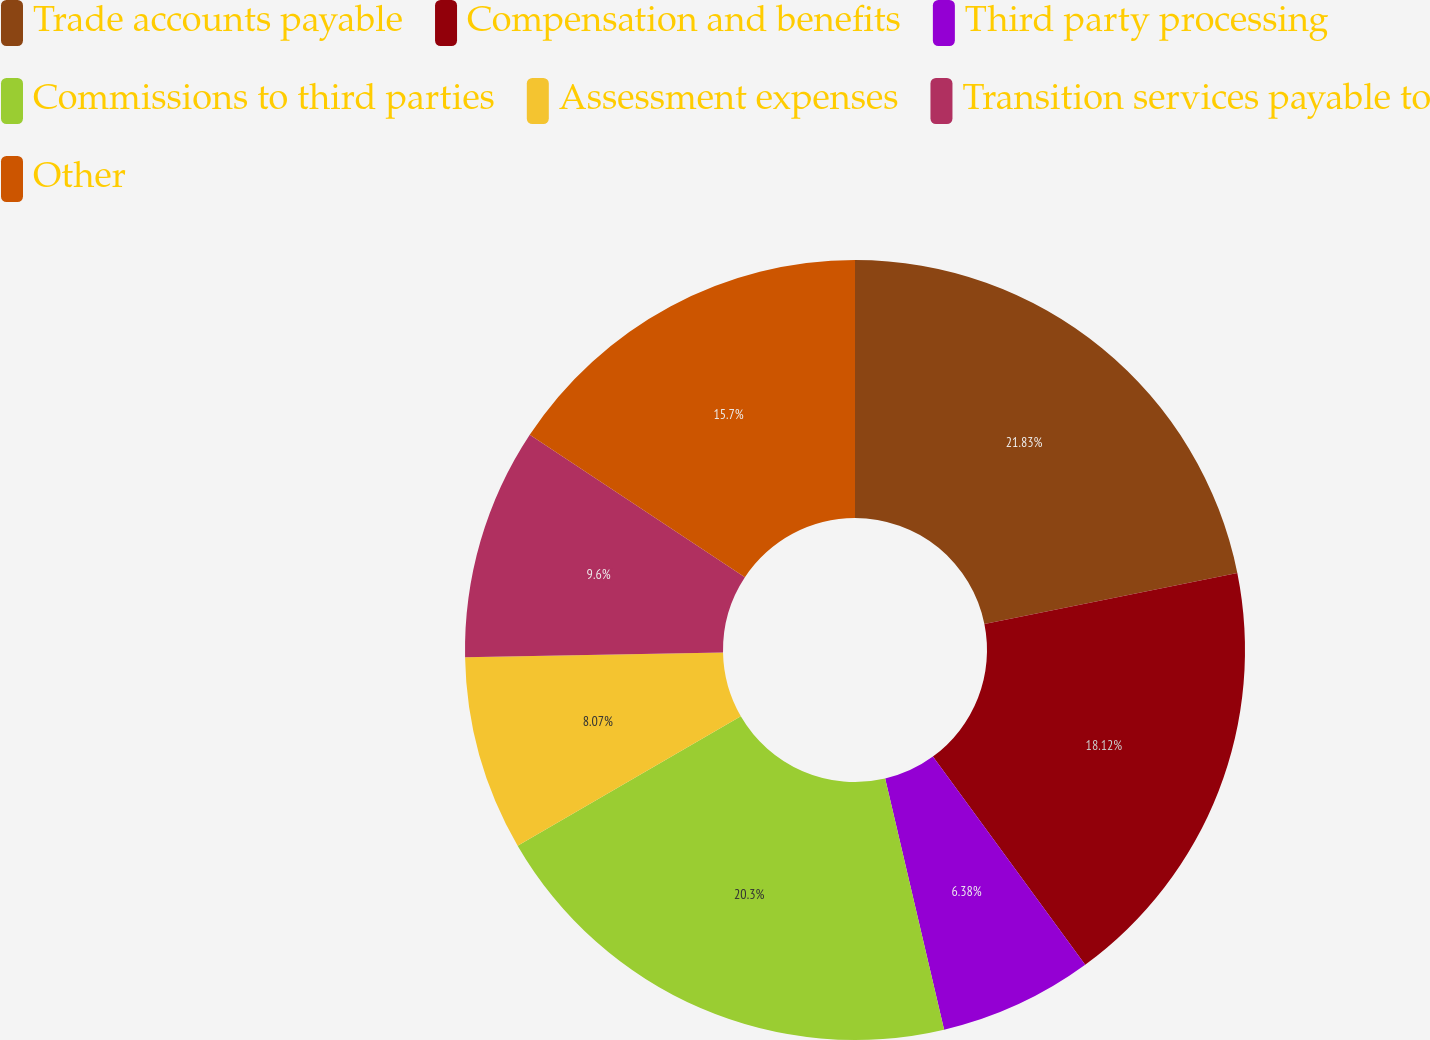Convert chart. <chart><loc_0><loc_0><loc_500><loc_500><pie_chart><fcel>Trade accounts payable<fcel>Compensation and benefits<fcel>Third party processing<fcel>Commissions to third parties<fcel>Assessment expenses<fcel>Transition services payable to<fcel>Other<nl><fcel>21.84%<fcel>18.12%<fcel>6.38%<fcel>20.31%<fcel>8.07%<fcel>9.6%<fcel>15.7%<nl></chart> 